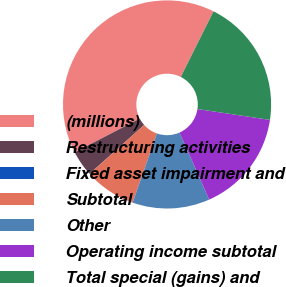Convert chart to OTSL. <chart><loc_0><loc_0><loc_500><loc_500><pie_chart><fcel>(millions)<fcel>Restructuring activities<fcel>Fixed asset impairment and<fcel>Subtotal<fcel>Other<fcel>Operating income subtotal<fcel>Total special (gains) and<nl><fcel>39.99%<fcel>4.01%<fcel>0.01%<fcel>8.0%<fcel>12.0%<fcel>16.0%<fcel>20.0%<nl></chart> 